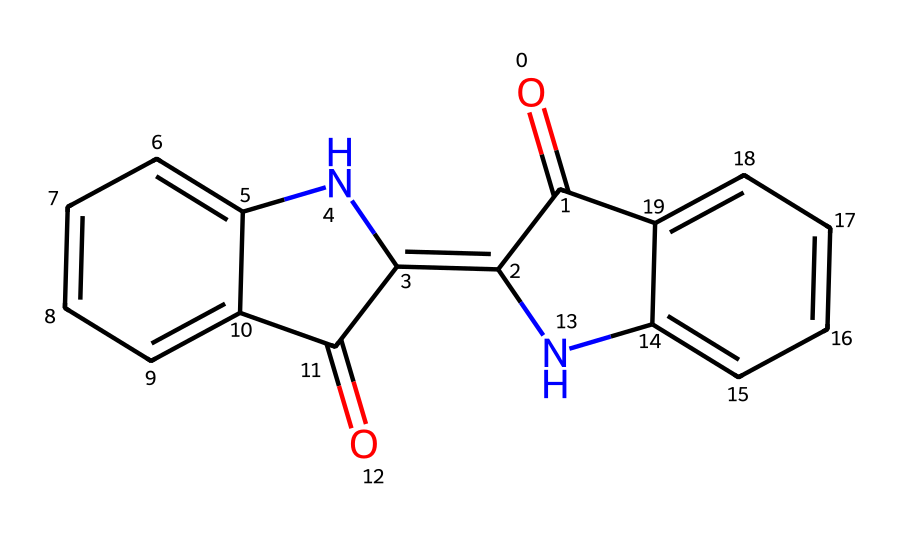What is the molecular formula of the compound represented by this SMILES? To determine the molecular formula, we need to count the number of each type of atom in the compound based on the SMILES representation. From analyzing the structure, we can identify the presence of 14 carbon atoms, 9 hydrogen atoms, 2 nitrogen atoms, and 2 oxygen atoms. Thus, the molecular formula is C14H9N2O2.
Answer: C14H9N2O2 How many rings are present in this structure? By closely examining the SMILES, we can note that there are multiple 'C' and 'N' atoms included in cyclic structures. Specifically, the numbering indicates four rings are formed from the connections of the atoms. Upon analysis, we confirm there are 4 distinct rings present in the structure.
Answer: 4 Does this compound contain a nitrile functional group? The nitrile functional group is characterized by a carbon triple-bonded to a nitrogen atom (C≡N). Looking at the structure, we find a nitrogen atom bonded to a carbon in a way that indicates a nitrile presence. Thus, we can confidently answer that this compound does indeed contain a nitrile functional group.
Answer: Yes What type of bonds predominantly exists in the compound? Upon analysis of the SMILES, we can observe both single and double bonds throughout the structure. The presence of double bonds is evident in the carbonyl groups and aromatic rings. Hence, we can conclude that this compound predominantly contains double bonds in the form of carbon-carbon and carbon-nitrogen double bonds alongside single bonds.
Answer: Double bonds What is the characteristic color produced by the dye from this compound? Traditionally, indigo dye is known for its rich blue color. This compound, natural indigo, is the source of that iconic blue color utilized in textiles. Thus, the characteristic color associated with this compound remains blue.
Answer: Blue 